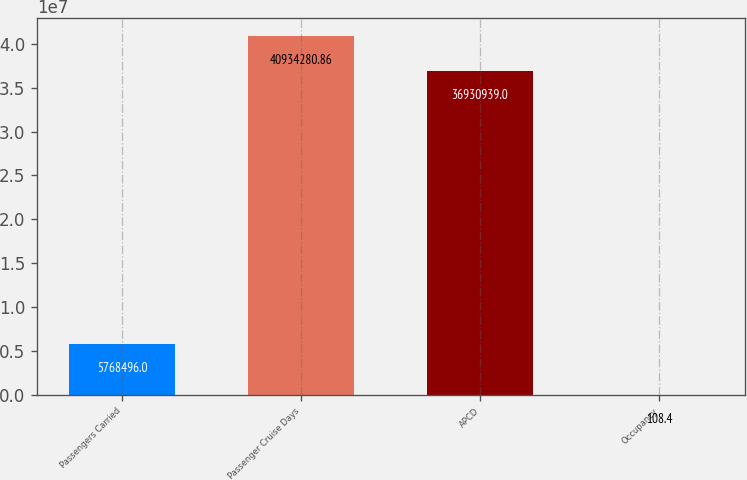Convert chart. <chart><loc_0><loc_0><loc_500><loc_500><bar_chart><fcel>Passengers Carried<fcel>Passenger Cruise Days<fcel>APCD<fcel>Occupancy<nl><fcel>5.7685e+06<fcel>4.09343e+07<fcel>3.69309e+07<fcel>108.4<nl></chart> 